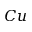Convert formula to latex. <formula><loc_0><loc_0><loc_500><loc_500>C u</formula> 